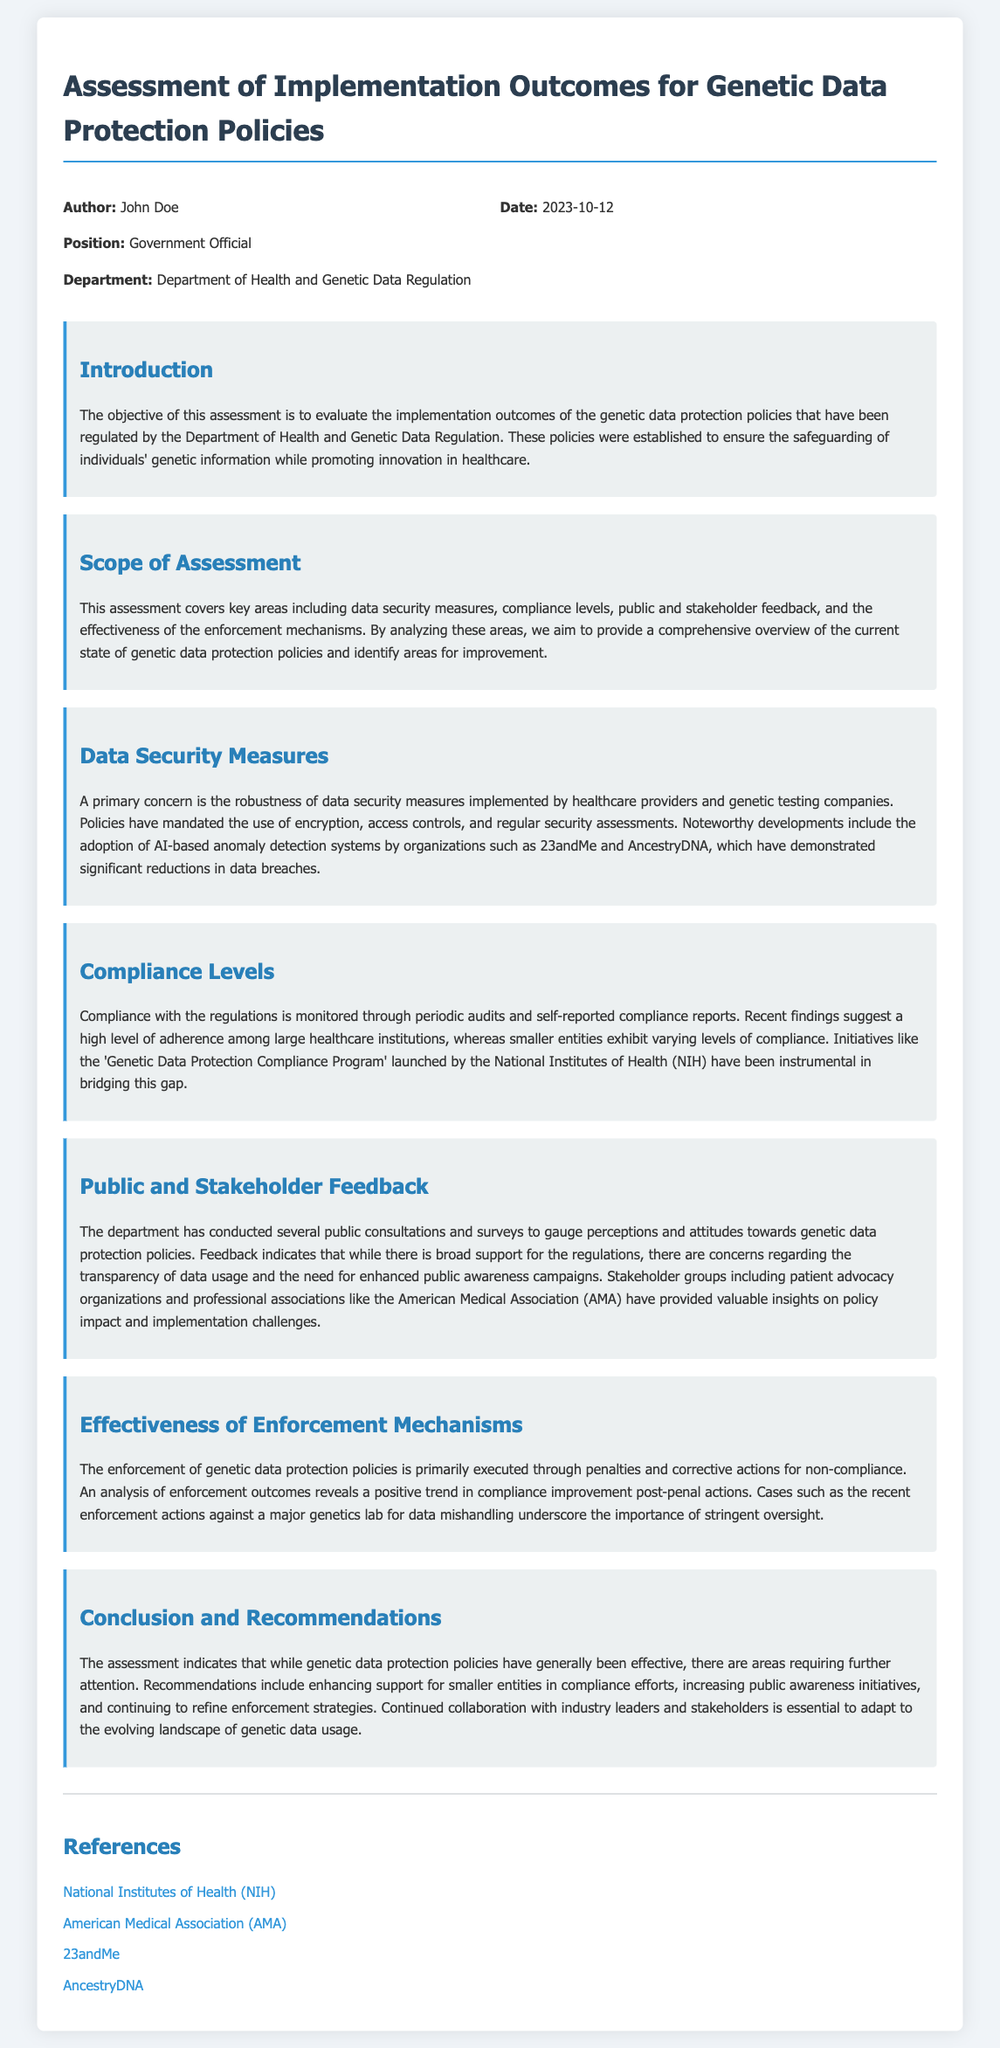What is the title of the document? The title of the document is located at the top of the content section.
Answer: Assessment of Implementation Outcomes for Genetic Data Protection Policies Who is the author of the document? The author's name is mentioned in the header information section.
Answer: John Doe What department is associated with the document? The relevant department is specified in the author details section.
Answer: Department of Health and Genetic Data Regulation When was the document created? The creation date is indicated in the header, near the author's information.
Answer: 2023-10-12 Which organization launched the 'Genetic Data Protection Compliance Program'? This information can be found in the compliance levels section discussing initiatives aiding compliance.
Answer: National Institutes of Health (NIH) What approach has been noted for data security by organizations? The document mentions specific measures taken by organizations regarding data security in the relevant section.
Answer: AI-based anomaly detection systems What is one recommendation made in the conclusion? The recommendations are summarized at the end of the document, highlighting areas for improvement.
Answer: Enhancing support for smaller entities in compliance efforts What type of feedback did the public provide regarding the regulations? The feedback section describes the nature of public support and concerns about the regulations.
Answer: Broad support but concerns regarding transparency How is compliance monitored according to the document? The compliance monitoring methods are described in the respective section of the document.
Answer: Periodic audits and self-reported compliance reports 